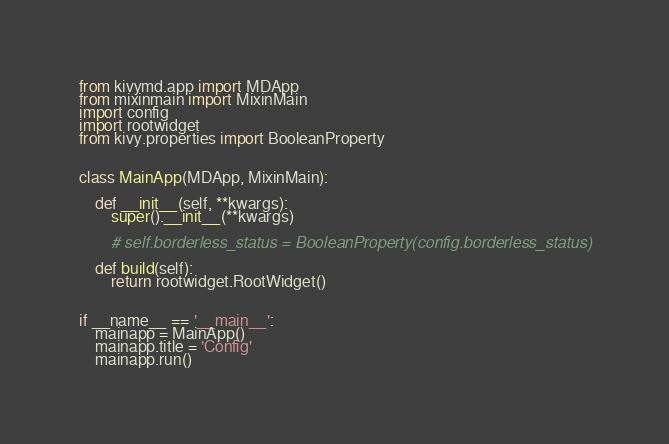Convert code to text. <code><loc_0><loc_0><loc_500><loc_500><_Python_>from kivymd.app import MDApp
from mixinmain import MixinMain
import config
import rootwidget
from kivy.properties import BooleanProperty


class MainApp(MDApp, MixinMain):

    def __init__(self, **kwargs):
        super().__init__(**kwargs)

        # self.borderless_status = BooleanProperty(config.borderless_status)

    def build(self):
        return rootwidget.RootWidget()


if __name__ == '__main__':
    mainapp = MainApp()
    mainapp.title = 'Config'
    mainapp.run()
</code> 